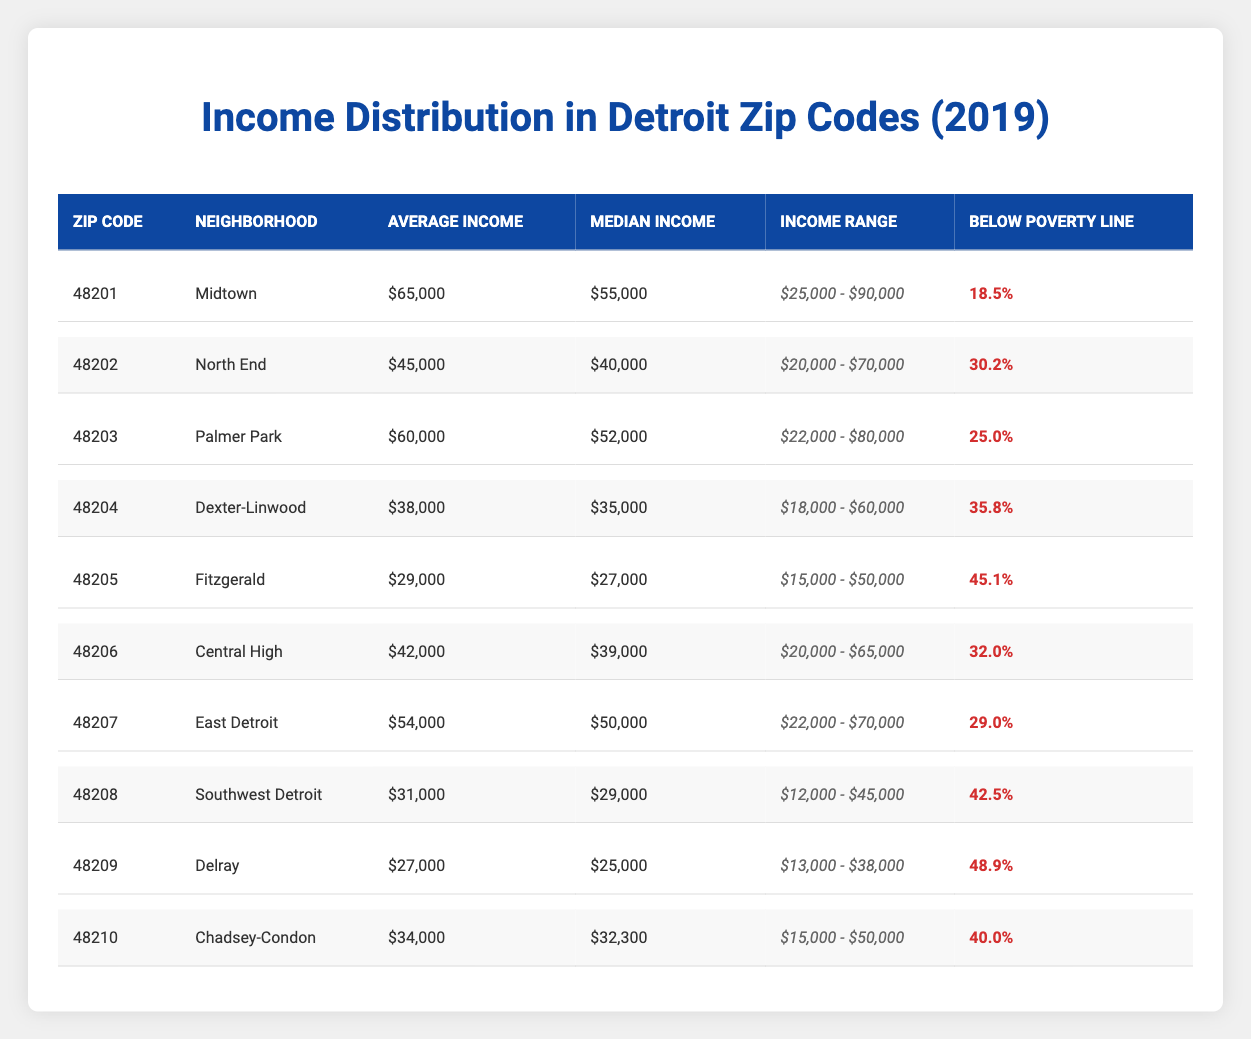What is the average income in the Midtown neighborhood? The average income for the Midtown neighborhood (Zip Code 48201) is provided in the table, which states that it is $65,000.
Answer: $65,000 Which zip code has the highest percentage of people below the poverty line? By examining the "Below Poverty Line" column, Delray (Zip Code 48209) has the highest percentage at 48.9%.
Answer: 48209 What is the median income in Palmer Park? The median income for Palmer Park (Zip Code 48203) is listed as $52,000 in the table.
Answer: $52,000 How much higher is the average income in Midtown compared to that in Dexter-Linwood? The average income in Midtown is $65,000, and in Dexter-Linwood it is $38,000. The difference is $65,000 - $38,000 = $27,000.
Answer: $27,000 Is the average income in Fitzgerald below $30,000? The table shows that the average income in Fitzgerald (Zip Code 48205) is $29,000, which is indeed below $30,000.
Answer: Yes What is the income range for East Detroit? The income range for East Detroit (Zip Code 48207) is provided as $22,000 - $70,000.
Answer: $22,000 - $70,000 If we take the average income of both the North End and Central High neighborhoods, what is the result? The average income for North End is $45,000 and for Central High it is $42,000. The combined total is $45,000 + $42,000 = $87,000, and the average is $87,000 / 2 = $43,500.
Answer: $43,500 Which neighborhood has a median income closest to $30,000? Comparing the median incomes, Southwest Detroit (Zip Code 48208) has a median income of $29,000, which is the closest to $30,000.
Answer: Southwest Detroit What is the average income for the neighborhoods with a poverty rate over 40%? The neighborhoods with poverty rates over 40% are Fitzgerald ($29,000), Southwest Detroit ($31,000), Delray ($27,000), and Chadsey-Condon ($34,000). The average is ($29,000 + $31,000 + $27,000 + $34,000) / 4 = $30,250.
Answer: $30,250 